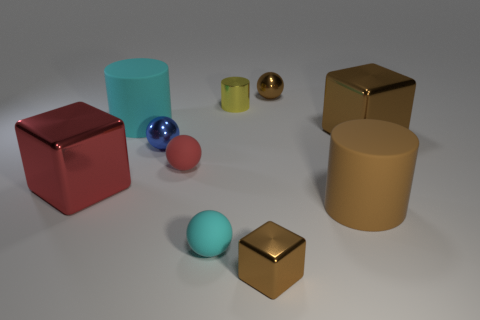Imagine these objects were part of a game, what kind of rules could be involved? If these objects were part of a game, one could imagine rules such as matching them by color or material properties, using them in a balance challenge, or assigning points based on their successful stacking or arrangement into specific patterns. 